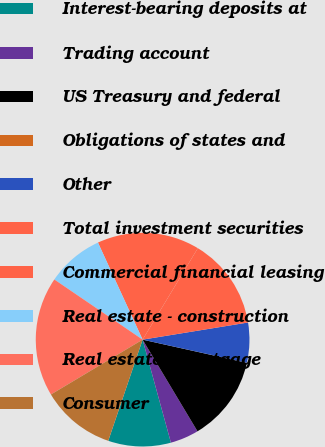Convert chart. <chart><loc_0><loc_0><loc_500><loc_500><pie_chart><fcel>Interest-bearing deposits at<fcel>Trading account<fcel>US Treasury and federal<fcel>Obligations of states and<fcel>Other<fcel>Total investment securities<fcel>Commercial financial leasing<fcel>Real estate - construction<fcel>Real estate - mortgage<fcel>Consumer<nl><fcel>9.48%<fcel>4.32%<fcel>12.93%<fcel>0.01%<fcel>6.04%<fcel>13.79%<fcel>15.51%<fcel>8.62%<fcel>18.1%<fcel>11.21%<nl></chart> 